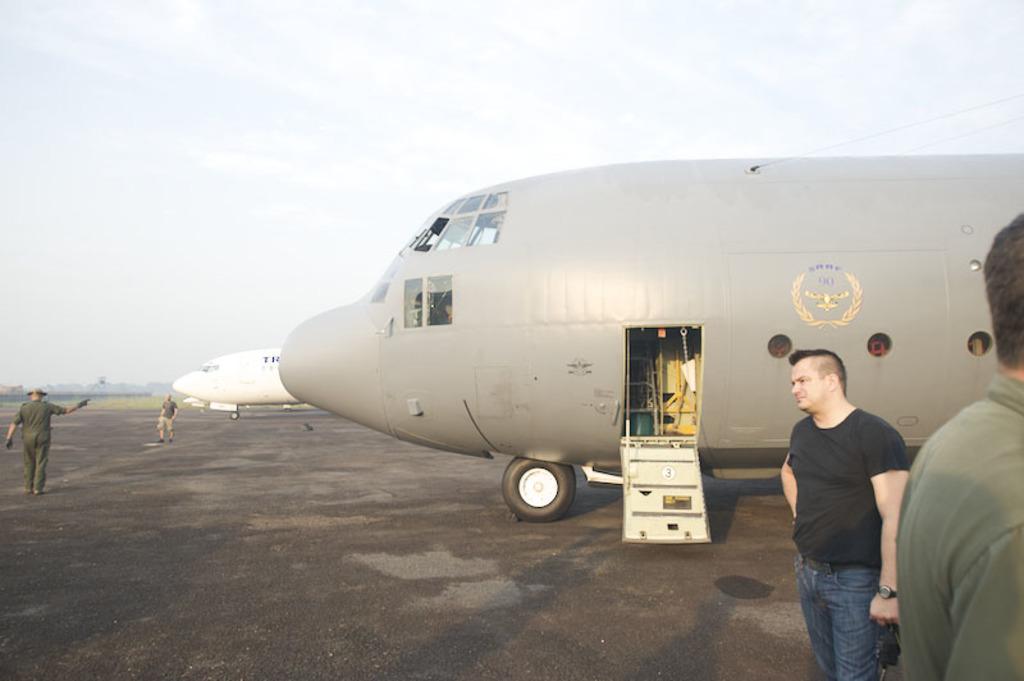Please provide a concise description of this image. This picture is clicked outside and we can see the group of persons. In the center we can see the airplanes parked on the ground. In the background we can see the sky and we can see some other objects. 